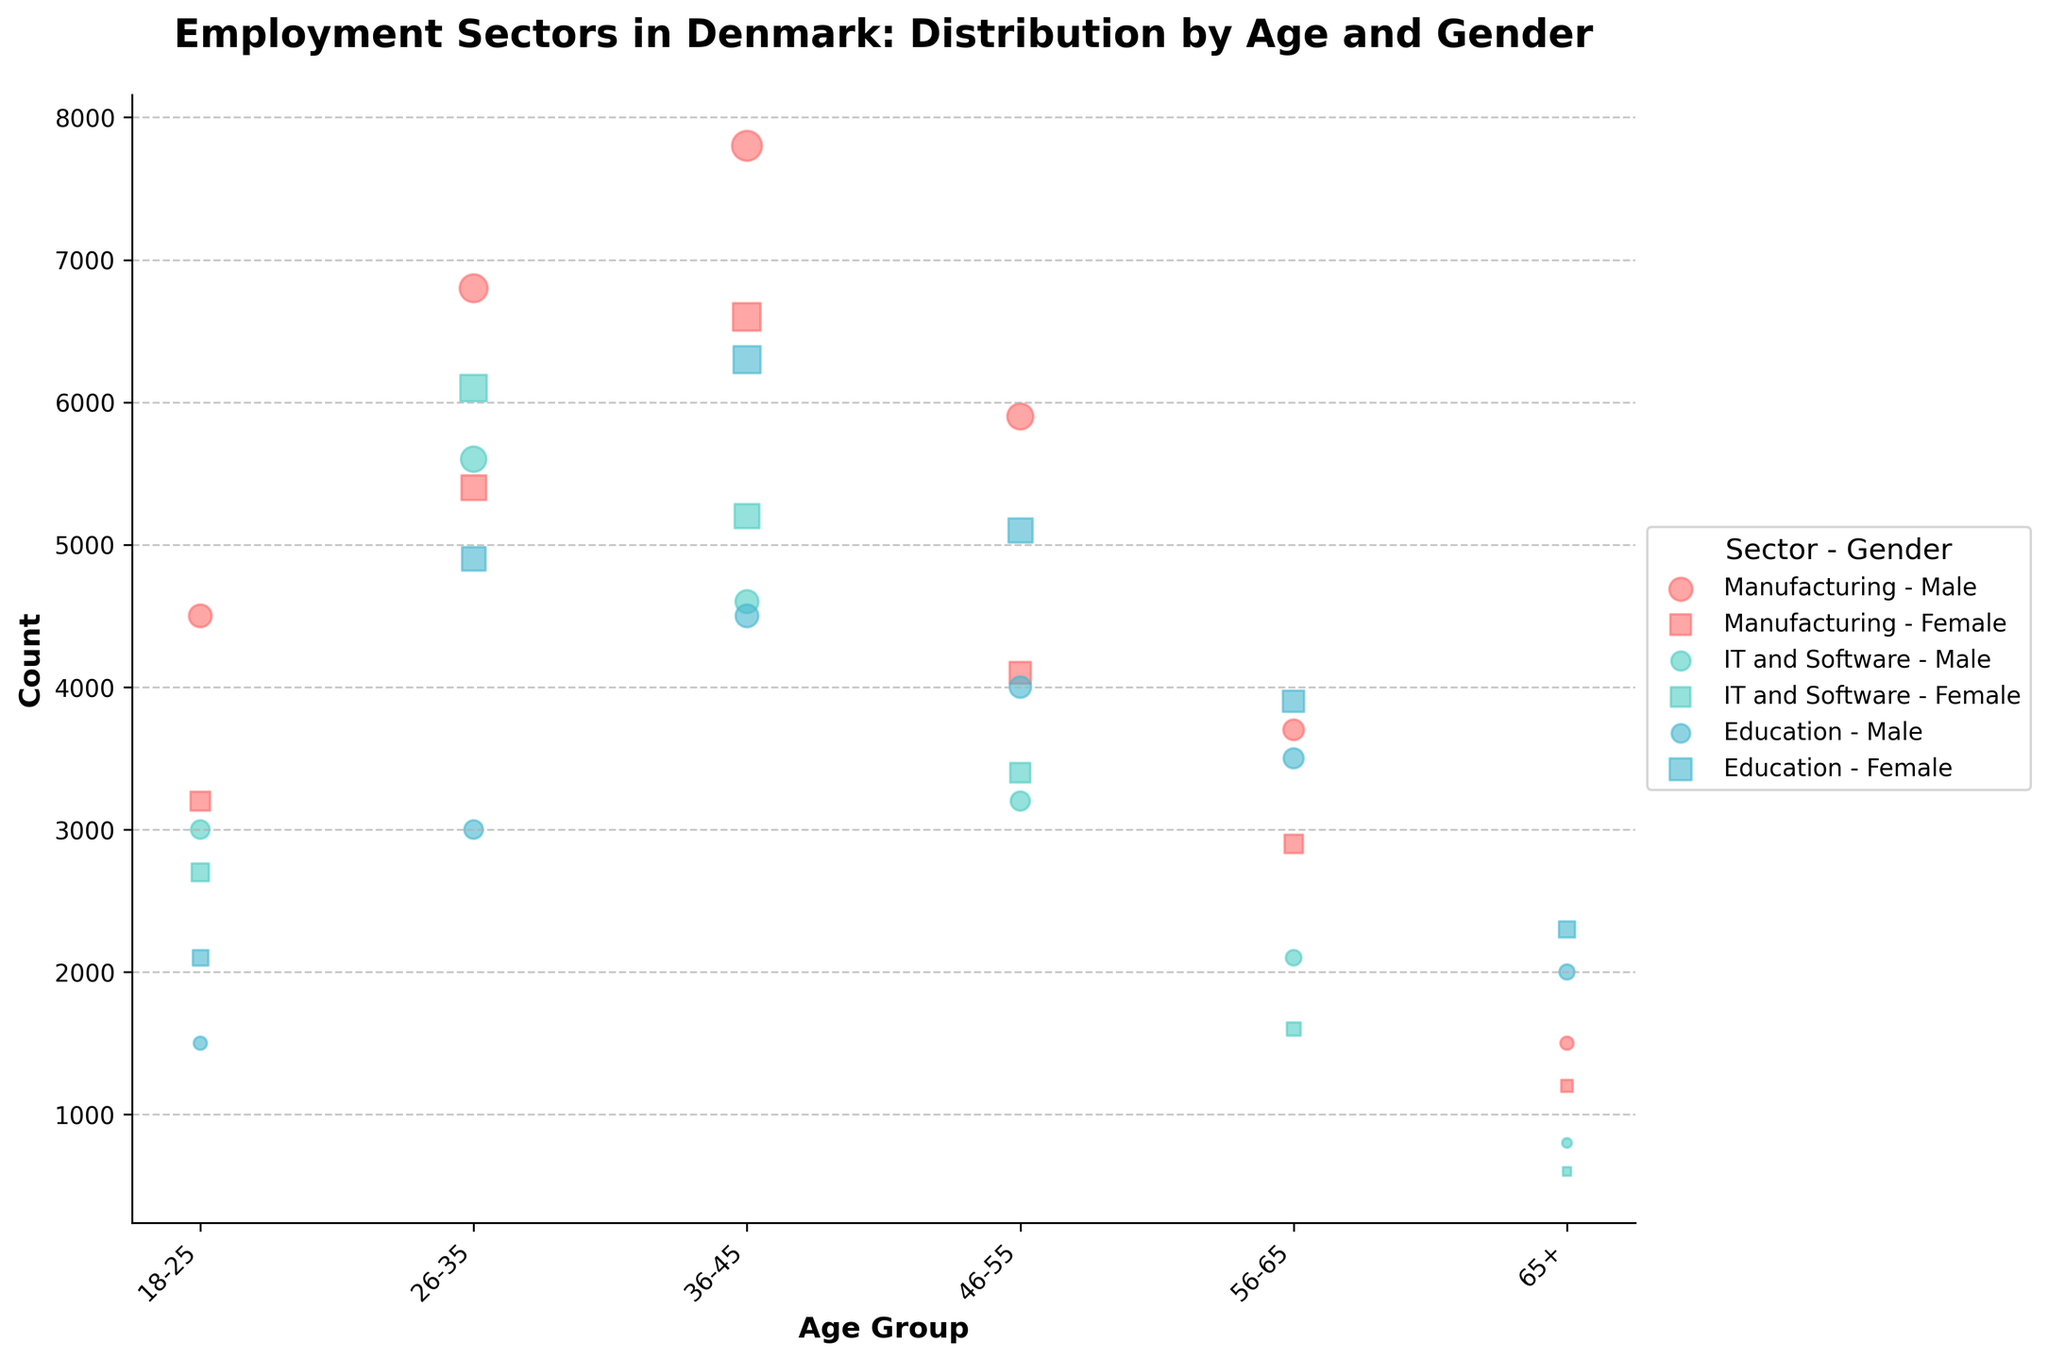What are the age groups shown on the x-axis? The x-axis labels represent different age groups in the figure. By closely observing the x-axis at the bottom of the chart, you can see the age groups: 18-25, 26-35, 36-45, 46-55, 56-65, and 65+.
Answer: 18-25, 26-35, 36-45, 46-55, 56-65, 65+ What is the title of the chart? The chart's title is positioned at the top of the figure in a bold font. It provides an overview of the subject of the chart: Employment Sectors in Denmark: Distribution by Age and Gender.
Answer: Employment Sectors in Denmark: Distribution by Age and Gender Which employment sector has the largest bubble for females in the age group 36-45? Looking specifically at the bubbles for females in the age group 36-45, you compare the sizes of the bubbles mapped to 'Education', 'Manufacturing', and 'IT and Software'. The largest bubble represents 'Education'.
Answer: Education How does the number of males in the Manufacturing sector change from age group 18-25 to 36-45? To determine the change, find the bubble sizes corresponding to males in 'Manufacturing' for age groups 18-25 and 36-45. The counts are 4500 and 7800, respectively. Subtract the former from the latter: 7800 - 4500 = 3300.
Answer: Increases by 3300 What age group has the highest count of females in IT and Software? For females in the IT and Software sector, examine the height of the bubbles across different age groups. The tallest bubble belongs to the age group 26-35 with a count of 6100.
Answer: 26-35 Which gender has a higher count in the Education sector for age group 56-65? Compare the sizes of bubbles for males and females in 'Education' for the age group 56-65. The female bubble represents a count of 3900, while the male bubble represents 3500.
Answer: Female What is the sum of males and females in the Manufacturing sector aged 26-35? Find the bubble sizes for both males and females in 'Manufacturing' for age group 26-35. The counts are 6800 and 5400, respectively. Add them together: 6800 + 5400 = 12200.
Answer: 12200 Which sector sees a decrease in female representation as the age group increases from 18-25 to 56-65? Examine the bubble sizes for females in each sector across increasing age groups. 'IT and Software' sector shows a decline: 2700 (18-25) to 1600 (56-65).
Answer: IT and Software Between age groups 46-55 and 65+, which sector shows the largest reduction in male employment? Compare the bubble sizes for males in each sector between 46-55 and 65+. The largest reduction is in 'Manufacturing': from 5900 to 1500, a decrease of 4400.
Answer: Manufacturing 